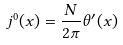Convert formula to latex. <formula><loc_0><loc_0><loc_500><loc_500>j ^ { 0 } ( x ) = \frac { N } { 2 \pi } \theta ^ { \prime } ( x )</formula> 